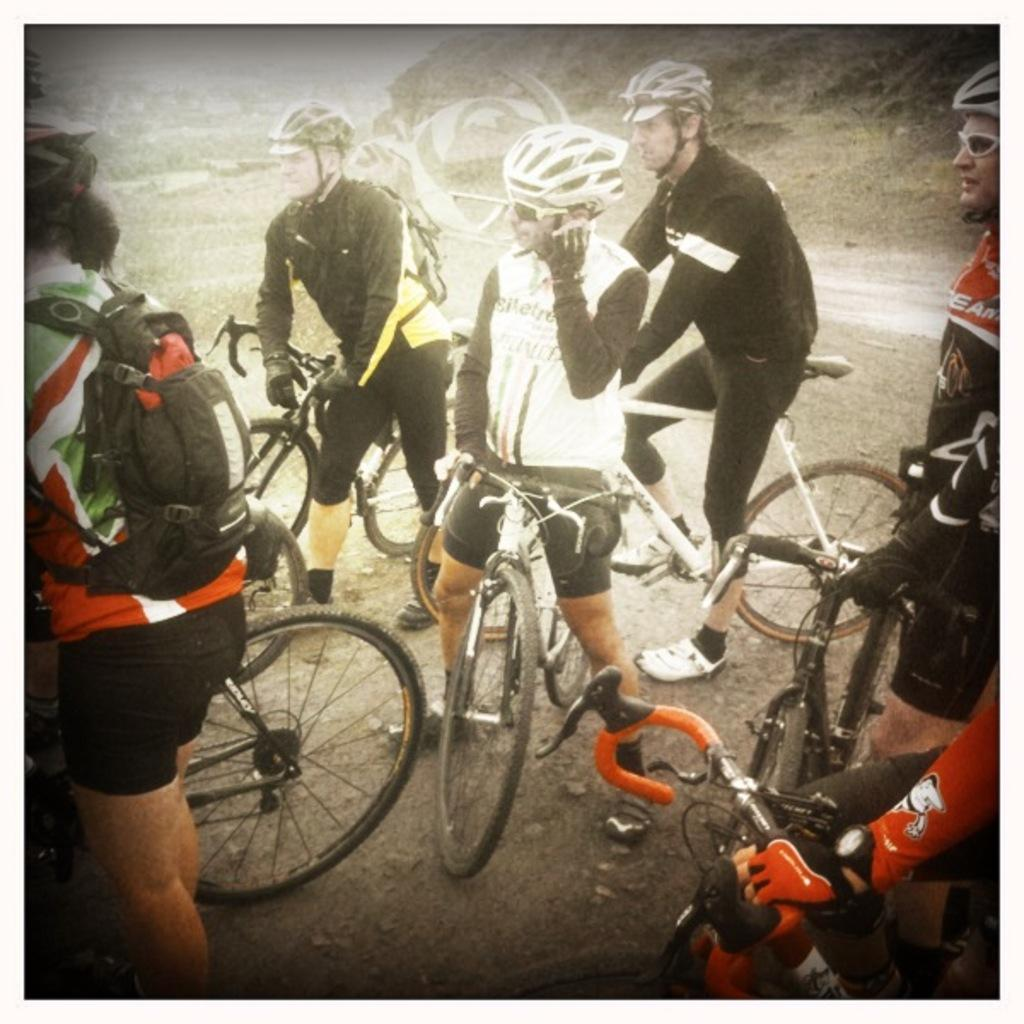How many people are in the image? There are multiple persons in the image. What are the persons doing in the image? The persons are with cycles. What type of yam is being served as a meal in the image? There is no meal or yam present in the image; the persons are with cycles. 